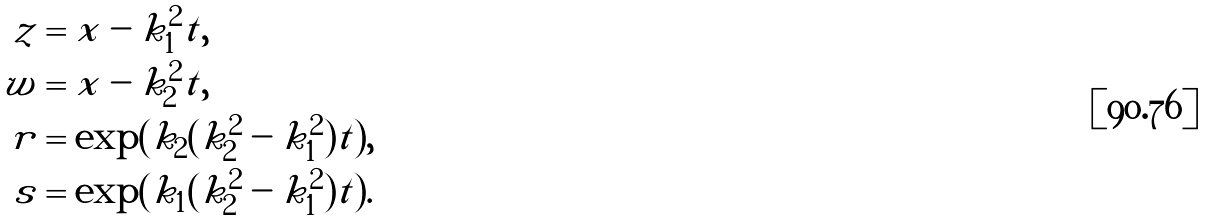Convert formula to latex. <formula><loc_0><loc_0><loc_500><loc_500>z & = x - k _ { 1 } ^ { 2 } t , \\ w & = x - k _ { 2 } ^ { 2 } t , \\ r & = \exp ( k _ { 2 } ( k _ { 2 } ^ { 2 } - k _ { 1 } ^ { 2 } ) t ) , \\ s & = \exp ( k _ { 1 } ( k _ { 2 } ^ { 2 } - k _ { 1 } ^ { 2 } ) t ) .</formula> 